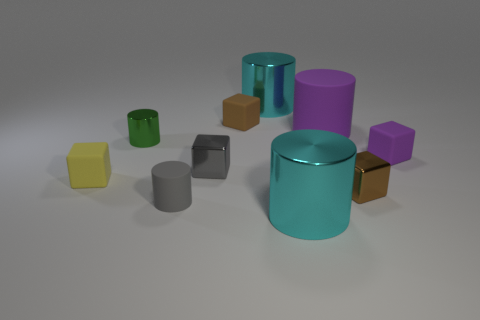Subtract 1 cylinders. How many cylinders are left? 4 Subtract all green cylinders. How many cylinders are left? 4 Subtract all yellow blocks. How many blocks are left? 4 Subtract all brown cylinders. Subtract all blue spheres. How many cylinders are left? 5 Add 4 brown objects. How many brown objects are left? 6 Add 7 cyan cylinders. How many cyan cylinders exist? 9 Subtract 0 red spheres. How many objects are left? 10 Subtract all green metallic objects. Subtract all small purple cubes. How many objects are left? 8 